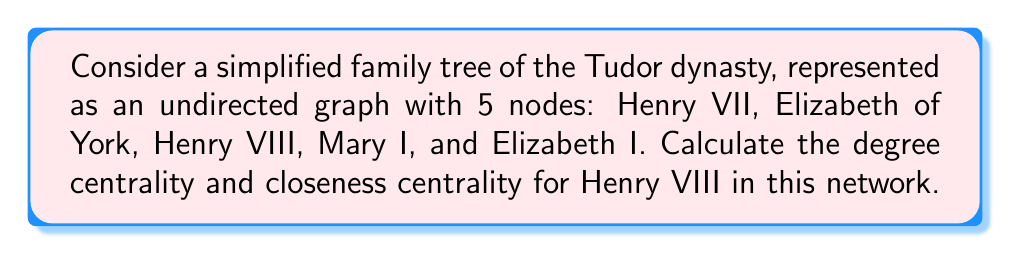Solve this math problem. To solve this problem, we need to understand the concepts of degree centrality and closeness centrality in network analysis, and then apply them to the given family tree.

1. Degree Centrality:
Degree centrality is the number of direct connections a node has. In an undirected graph, it's simply the number of edges connected to the node.

For Henry VIII:
- Connected to Henry VII (father)
- Connected to Elizabeth of York (mother)
- Connected to Mary I (daughter)
- Connected to Elizabeth I (daughter)

Degree centrality = 4

2. Closeness Centrality:
Closeness centrality measures how close a node is to all other nodes in the network. It's calculated as:

$$ C_C(v) = \frac{n-1}{\sum_{u \neq v} d(v,u)} $$

Where:
- $n$ is the number of nodes in the network
- $d(v,u)$ is the shortest path distance between nodes $v$ and $u$

Let's calculate the shortest path distances from Henry VIII to all other nodes:
- To Henry VII: 1
- To Elizabeth of York: 1
- To Mary I: 1
- To Elizabeth I: 1

Sum of shortest paths: $1 + 1 + 1 + 1 = 4$

Now, we can apply the formula:

$$ C_C(\text{Henry VIII}) = \frac{5-1}{4} = \frac{4}{4} = 1 $$
Answer: Degree Centrality of Henry VIII: 4
Closeness Centrality of Henry VIII: 1 